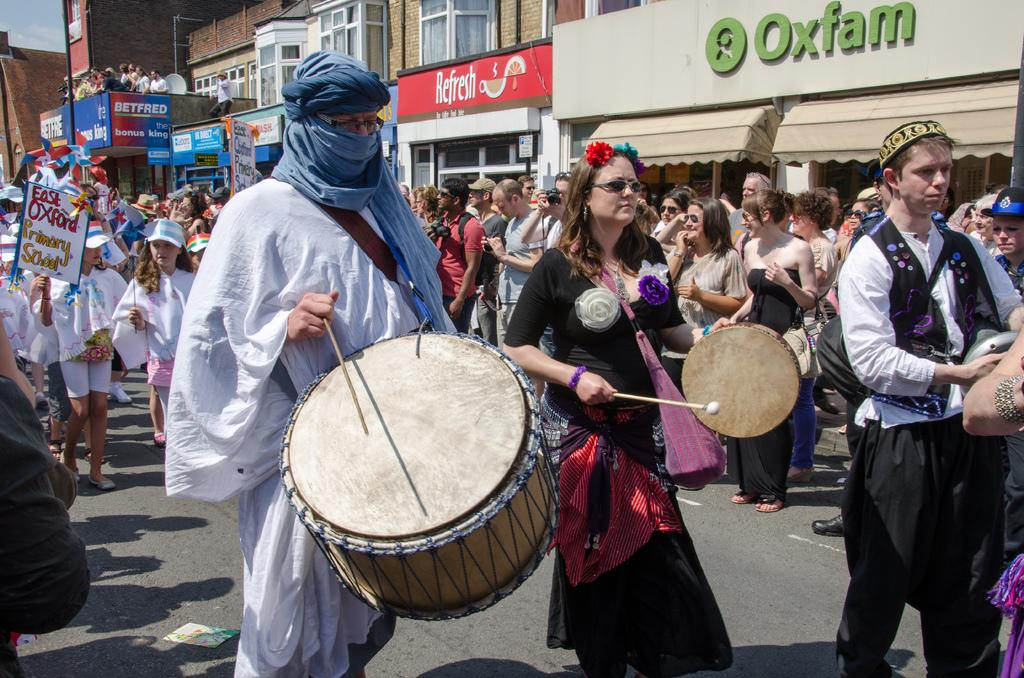What type of structures can be seen in the image? There are buildings in the image. What are the people in the image doing? There are people walking in the streets, and a man and a woman are playing drums in the image. Can you describe the musical instruments being played in the image? A man is playing drums, and a woman is playing a small drum in the image. What type of brush is the man using to paint the buildings in the image? There is no brush or painting activity present in the image; the man is playing drums. Can you see an airplane flying over the buildings in the image? There is no airplane visible in the image; it only features buildings, people walking, and the two individuals playing drums. 